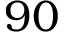<formula> <loc_0><loc_0><loc_500><loc_500>9 0</formula> 